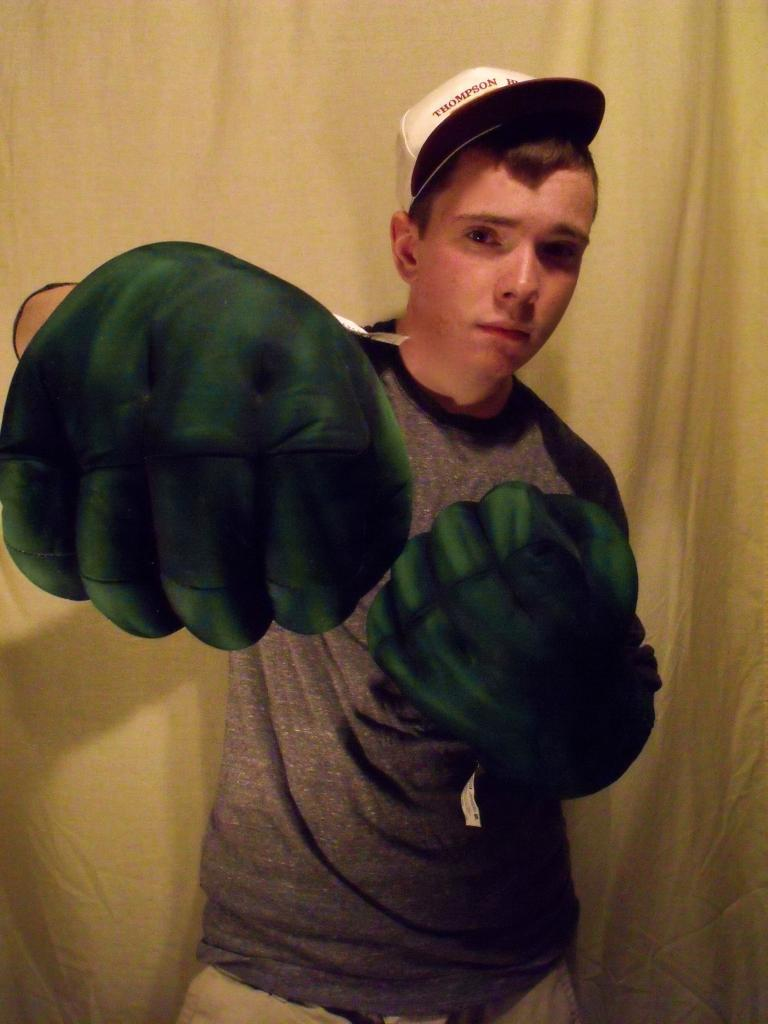What is the main subject of the image? There is a man standing in the image. What is the man wearing on his head? The man is wearing a cap. What is the man wearing on his hands? The man is wearing gloves on his hands. What can be seen in the background of the image? There is a curtain in the background of the image. What type of amusement can be seen in the image? There is no amusement present in the image; it features a man standing with a cap and gloves, and a curtain in the background. Can you tell me how many basketballs are visible in the image? There are no basketballs present in the image. 